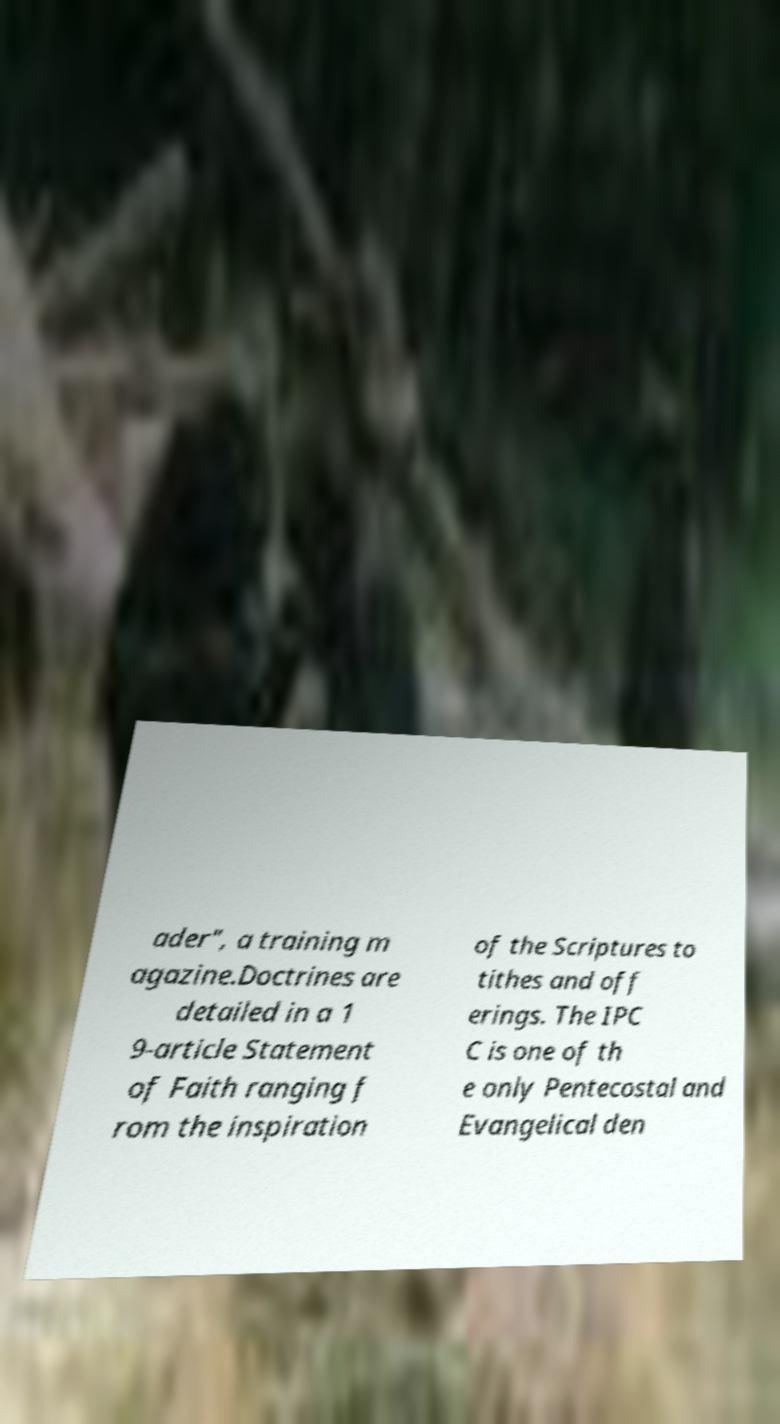Can you accurately transcribe the text from the provided image for me? ader", a training m agazine.Doctrines are detailed in a 1 9-article Statement of Faith ranging f rom the inspiration of the Scriptures to tithes and off erings. The IPC C is one of th e only Pentecostal and Evangelical den 